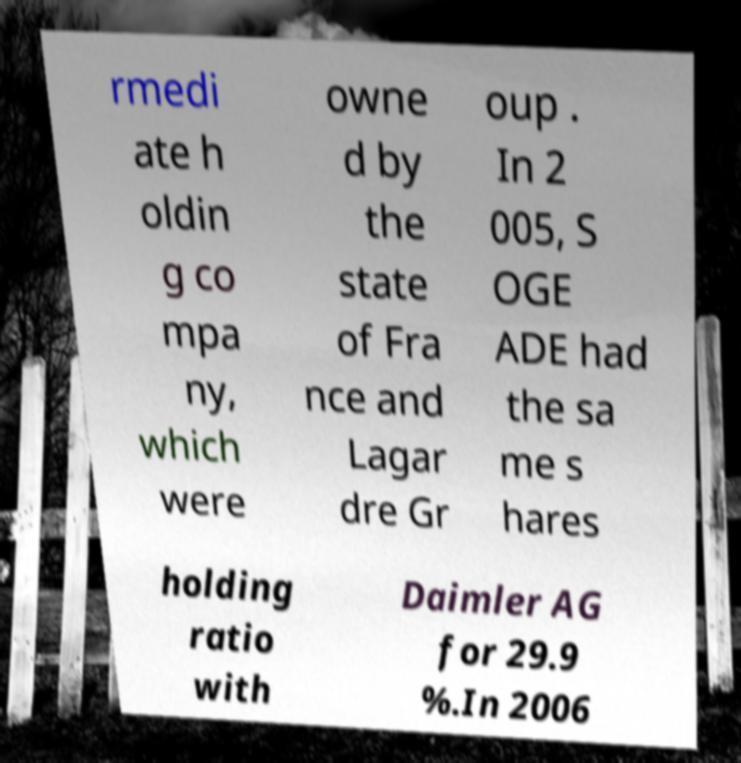For documentation purposes, I need the text within this image transcribed. Could you provide that? rmedi ate h oldin g co mpa ny, which were owne d by the state of Fra nce and Lagar dre Gr oup . In 2 005, S OGE ADE had the sa me s hares holding ratio with Daimler AG for 29.9 %.In 2006 